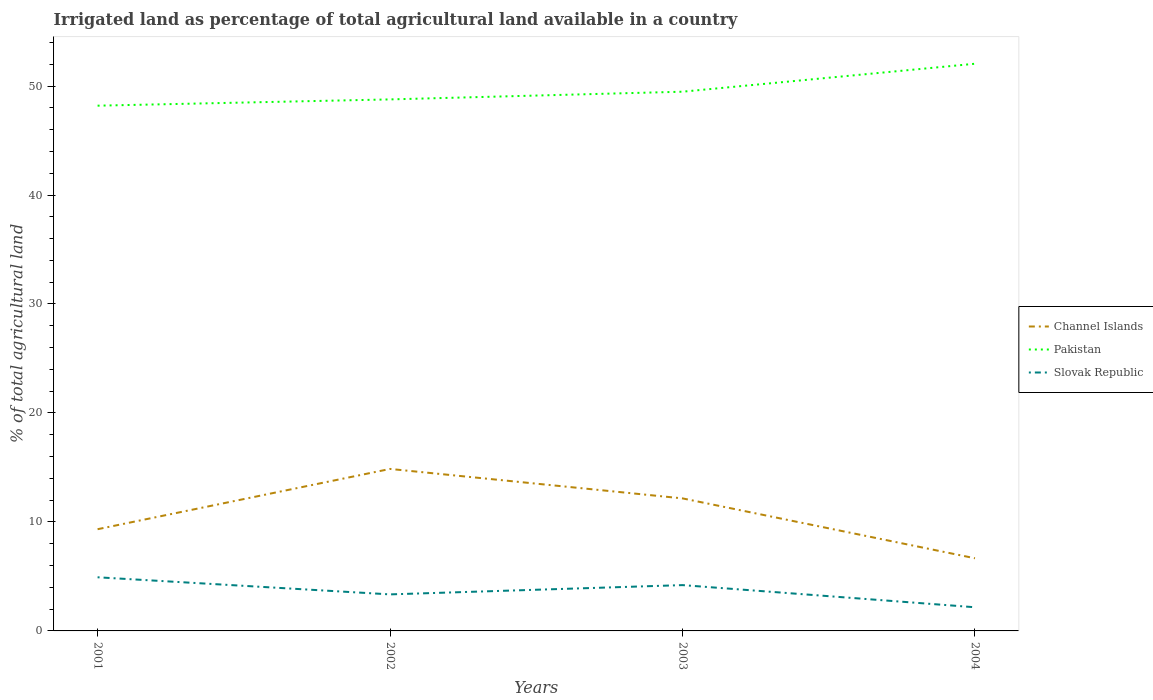Does the line corresponding to Pakistan intersect with the line corresponding to Channel Islands?
Keep it short and to the point. No. Across all years, what is the maximum percentage of irrigated land in Channel Islands?
Ensure brevity in your answer.  6.67. What is the total percentage of irrigated land in Channel Islands in the graph?
Your answer should be very brief. 8.2. What is the difference between the highest and the second highest percentage of irrigated land in Pakistan?
Provide a short and direct response. 3.85. Is the percentage of irrigated land in Channel Islands strictly greater than the percentage of irrigated land in Pakistan over the years?
Offer a very short reply. Yes. Are the values on the major ticks of Y-axis written in scientific E-notation?
Offer a very short reply. No. Where does the legend appear in the graph?
Provide a succinct answer. Center right. How many legend labels are there?
Offer a very short reply. 3. What is the title of the graph?
Give a very brief answer. Irrigated land as percentage of total agricultural land available in a country. Does "Norway" appear as one of the legend labels in the graph?
Offer a very short reply. No. What is the label or title of the X-axis?
Offer a very short reply. Years. What is the label or title of the Y-axis?
Keep it short and to the point. % of total agricultural land. What is the % of total agricultural land of Channel Islands in 2001?
Provide a short and direct response. 9.33. What is the % of total agricultural land of Pakistan in 2001?
Provide a succinct answer. 48.2. What is the % of total agricultural land of Slovak Republic in 2001?
Provide a short and direct response. 4.92. What is the % of total agricultural land in Channel Islands in 2002?
Give a very brief answer. 14.86. What is the % of total agricultural land of Pakistan in 2002?
Make the answer very short. 48.77. What is the % of total agricultural land of Slovak Republic in 2002?
Give a very brief answer. 3.35. What is the % of total agricultural land in Channel Islands in 2003?
Your answer should be very brief. 12.16. What is the % of total agricultural land of Pakistan in 2003?
Offer a very short reply. 49.48. What is the % of total agricultural land in Slovak Republic in 2003?
Keep it short and to the point. 4.2. What is the % of total agricultural land of Channel Islands in 2004?
Offer a terse response. 6.67. What is the % of total agricultural land in Pakistan in 2004?
Offer a very short reply. 52.05. What is the % of total agricultural land of Slovak Republic in 2004?
Offer a terse response. 2.17. Across all years, what is the maximum % of total agricultural land in Channel Islands?
Offer a terse response. 14.86. Across all years, what is the maximum % of total agricultural land of Pakistan?
Give a very brief answer. 52.05. Across all years, what is the maximum % of total agricultural land of Slovak Republic?
Provide a succinct answer. 4.92. Across all years, what is the minimum % of total agricultural land of Channel Islands?
Ensure brevity in your answer.  6.67. Across all years, what is the minimum % of total agricultural land of Pakistan?
Provide a succinct answer. 48.2. Across all years, what is the minimum % of total agricultural land in Slovak Republic?
Keep it short and to the point. 2.17. What is the total % of total agricultural land in Channel Islands in the graph?
Your answer should be very brief. 43.03. What is the total % of total agricultural land in Pakistan in the graph?
Provide a short and direct response. 198.5. What is the total % of total agricultural land of Slovak Republic in the graph?
Make the answer very short. 14.65. What is the difference between the % of total agricultural land in Channel Islands in 2001 and that in 2002?
Your answer should be compact. -5.53. What is the difference between the % of total agricultural land in Pakistan in 2001 and that in 2002?
Give a very brief answer. -0.58. What is the difference between the % of total agricultural land in Slovak Republic in 2001 and that in 2002?
Provide a succinct answer. 1.57. What is the difference between the % of total agricultural land of Channel Islands in 2001 and that in 2003?
Your answer should be very brief. -2.83. What is the difference between the % of total agricultural land of Pakistan in 2001 and that in 2003?
Offer a very short reply. -1.28. What is the difference between the % of total agricultural land of Slovak Republic in 2001 and that in 2003?
Offer a very short reply. 0.72. What is the difference between the % of total agricultural land of Channel Islands in 2001 and that in 2004?
Your answer should be very brief. 2.67. What is the difference between the % of total agricultural land of Pakistan in 2001 and that in 2004?
Provide a short and direct response. -3.85. What is the difference between the % of total agricultural land of Slovak Republic in 2001 and that in 2004?
Make the answer very short. 2.75. What is the difference between the % of total agricultural land in Channel Islands in 2002 and that in 2003?
Your answer should be very brief. 2.7. What is the difference between the % of total agricultural land in Pakistan in 2002 and that in 2003?
Keep it short and to the point. -0.71. What is the difference between the % of total agricultural land in Slovak Republic in 2002 and that in 2003?
Provide a short and direct response. -0.85. What is the difference between the % of total agricultural land of Channel Islands in 2002 and that in 2004?
Provide a short and direct response. 8.2. What is the difference between the % of total agricultural land in Pakistan in 2002 and that in 2004?
Offer a very short reply. -3.27. What is the difference between the % of total agricultural land in Slovak Republic in 2002 and that in 2004?
Ensure brevity in your answer.  1.18. What is the difference between the % of total agricultural land in Channel Islands in 2003 and that in 2004?
Your answer should be very brief. 5.5. What is the difference between the % of total agricultural land in Pakistan in 2003 and that in 2004?
Keep it short and to the point. -2.56. What is the difference between the % of total agricultural land of Slovak Republic in 2003 and that in 2004?
Offer a terse response. 2.03. What is the difference between the % of total agricultural land of Channel Islands in 2001 and the % of total agricultural land of Pakistan in 2002?
Your response must be concise. -39.44. What is the difference between the % of total agricultural land of Channel Islands in 2001 and the % of total agricultural land of Slovak Republic in 2002?
Your answer should be very brief. 5.98. What is the difference between the % of total agricultural land of Pakistan in 2001 and the % of total agricultural land of Slovak Republic in 2002?
Your answer should be very brief. 44.85. What is the difference between the % of total agricultural land in Channel Islands in 2001 and the % of total agricultural land in Pakistan in 2003?
Keep it short and to the point. -40.15. What is the difference between the % of total agricultural land of Channel Islands in 2001 and the % of total agricultural land of Slovak Republic in 2003?
Keep it short and to the point. 5.13. What is the difference between the % of total agricultural land of Pakistan in 2001 and the % of total agricultural land of Slovak Republic in 2003?
Provide a succinct answer. 43.99. What is the difference between the % of total agricultural land in Channel Islands in 2001 and the % of total agricultural land in Pakistan in 2004?
Your answer should be compact. -42.71. What is the difference between the % of total agricultural land of Channel Islands in 2001 and the % of total agricultural land of Slovak Republic in 2004?
Make the answer very short. 7.16. What is the difference between the % of total agricultural land in Pakistan in 2001 and the % of total agricultural land in Slovak Republic in 2004?
Ensure brevity in your answer.  46.03. What is the difference between the % of total agricultural land of Channel Islands in 2002 and the % of total agricultural land of Pakistan in 2003?
Provide a succinct answer. -34.62. What is the difference between the % of total agricultural land of Channel Islands in 2002 and the % of total agricultural land of Slovak Republic in 2003?
Offer a very short reply. 10.66. What is the difference between the % of total agricultural land in Pakistan in 2002 and the % of total agricultural land in Slovak Republic in 2003?
Give a very brief answer. 44.57. What is the difference between the % of total agricultural land of Channel Islands in 2002 and the % of total agricultural land of Pakistan in 2004?
Your answer should be compact. -37.18. What is the difference between the % of total agricultural land of Channel Islands in 2002 and the % of total agricultural land of Slovak Republic in 2004?
Give a very brief answer. 12.69. What is the difference between the % of total agricultural land of Pakistan in 2002 and the % of total agricultural land of Slovak Republic in 2004?
Your answer should be compact. 46.6. What is the difference between the % of total agricultural land in Channel Islands in 2003 and the % of total agricultural land in Pakistan in 2004?
Give a very brief answer. -39.88. What is the difference between the % of total agricultural land in Channel Islands in 2003 and the % of total agricultural land in Slovak Republic in 2004?
Offer a very short reply. 9.99. What is the difference between the % of total agricultural land in Pakistan in 2003 and the % of total agricultural land in Slovak Republic in 2004?
Keep it short and to the point. 47.31. What is the average % of total agricultural land in Channel Islands per year?
Your answer should be compact. 10.76. What is the average % of total agricultural land in Pakistan per year?
Provide a succinct answer. 49.63. What is the average % of total agricultural land of Slovak Republic per year?
Ensure brevity in your answer.  3.66. In the year 2001, what is the difference between the % of total agricultural land of Channel Islands and % of total agricultural land of Pakistan?
Your answer should be compact. -38.87. In the year 2001, what is the difference between the % of total agricultural land in Channel Islands and % of total agricultural land in Slovak Republic?
Your response must be concise. 4.41. In the year 2001, what is the difference between the % of total agricultural land of Pakistan and % of total agricultural land of Slovak Republic?
Provide a succinct answer. 43.28. In the year 2002, what is the difference between the % of total agricultural land in Channel Islands and % of total agricultural land in Pakistan?
Your answer should be compact. -33.91. In the year 2002, what is the difference between the % of total agricultural land in Channel Islands and % of total agricultural land in Slovak Republic?
Ensure brevity in your answer.  11.51. In the year 2002, what is the difference between the % of total agricultural land of Pakistan and % of total agricultural land of Slovak Republic?
Offer a terse response. 45.42. In the year 2003, what is the difference between the % of total agricultural land of Channel Islands and % of total agricultural land of Pakistan?
Give a very brief answer. -37.32. In the year 2003, what is the difference between the % of total agricultural land in Channel Islands and % of total agricultural land in Slovak Republic?
Your response must be concise. 7.96. In the year 2003, what is the difference between the % of total agricultural land of Pakistan and % of total agricultural land of Slovak Republic?
Provide a succinct answer. 45.28. In the year 2004, what is the difference between the % of total agricultural land in Channel Islands and % of total agricultural land in Pakistan?
Provide a succinct answer. -45.38. In the year 2004, what is the difference between the % of total agricultural land of Channel Islands and % of total agricultural land of Slovak Republic?
Give a very brief answer. 4.5. In the year 2004, what is the difference between the % of total agricultural land in Pakistan and % of total agricultural land in Slovak Republic?
Give a very brief answer. 49.87. What is the ratio of the % of total agricultural land of Channel Islands in 2001 to that in 2002?
Give a very brief answer. 0.63. What is the ratio of the % of total agricultural land of Slovak Republic in 2001 to that in 2002?
Keep it short and to the point. 1.47. What is the ratio of the % of total agricultural land of Channel Islands in 2001 to that in 2003?
Ensure brevity in your answer.  0.77. What is the ratio of the % of total agricultural land of Pakistan in 2001 to that in 2003?
Your answer should be compact. 0.97. What is the ratio of the % of total agricultural land of Slovak Republic in 2001 to that in 2003?
Make the answer very short. 1.17. What is the ratio of the % of total agricultural land of Pakistan in 2001 to that in 2004?
Offer a terse response. 0.93. What is the ratio of the % of total agricultural land of Slovak Republic in 2001 to that in 2004?
Your answer should be very brief. 2.27. What is the ratio of the % of total agricultural land in Channel Islands in 2002 to that in 2003?
Make the answer very short. 1.22. What is the ratio of the % of total agricultural land in Pakistan in 2002 to that in 2003?
Your answer should be very brief. 0.99. What is the ratio of the % of total agricultural land of Slovak Republic in 2002 to that in 2003?
Your answer should be compact. 0.8. What is the ratio of the % of total agricultural land of Channel Islands in 2002 to that in 2004?
Make the answer very short. 2.23. What is the ratio of the % of total agricultural land in Pakistan in 2002 to that in 2004?
Make the answer very short. 0.94. What is the ratio of the % of total agricultural land in Slovak Republic in 2002 to that in 2004?
Make the answer very short. 1.54. What is the ratio of the % of total agricultural land in Channel Islands in 2003 to that in 2004?
Make the answer very short. 1.82. What is the ratio of the % of total agricultural land in Pakistan in 2003 to that in 2004?
Provide a succinct answer. 0.95. What is the ratio of the % of total agricultural land in Slovak Republic in 2003 to that in 2004?
Give a very brief answer. 1.94. What is the difference between the highest and the second highest % of total agricultural land of Channel Islands?
Provide a short and direct response. 2.7. What is the difference between the highest and the second highest % of total agricultural land of Pakistan?
Make the answer very short. 2.56. What is the difference between the highest and the second highest % of total agricultural land of Slovak Republic?
Keep it short and to the point. 0.72. What is the difference between the highest and the lowest % of total agricultural land in Channel Islands?
Offer a very short reply. 8.2. What is the difference between the highest and the lowest % of total agricultural land in Pakistan?
Ensure brevity in your answer.  3.85. What is the difference between the highest and the lowest % of total agricultural land in Slovak Republic?
Ensure brevity in your answer.  2.75. 